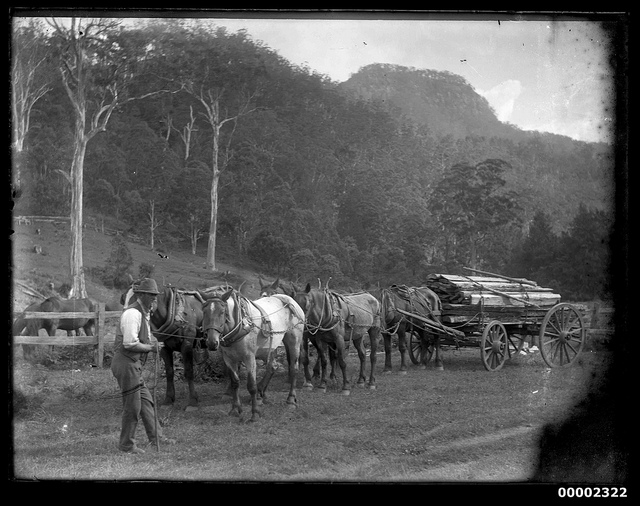<image>What language is this photo captioned with? I am not sure about the language of the photo caption. It can be English or there may be no caption at all. What language is this photo captioned with? The language of the photo caption is English. 